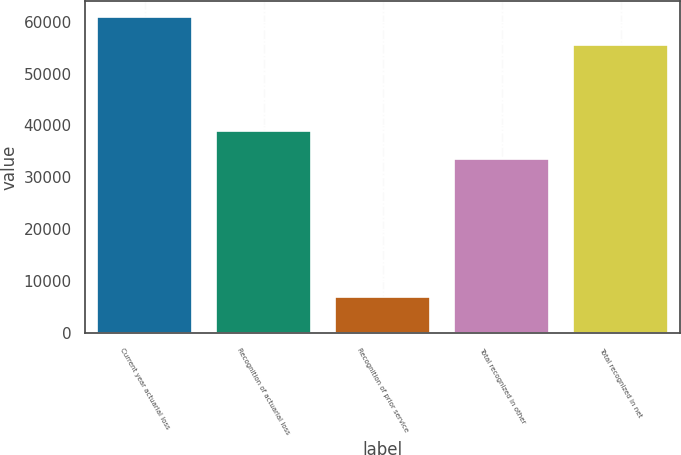<chart> <loc_0><loc_0><loc_500><loc_500><bar_chart><fcel>Current year actuarial loss<fcel>Recognition of actuarial loss<fcel>Recognition of prior service<fcel>Total recognized in other<fcel>Total recognized in net<nl><fcel>60903.8<fcel>39019.8<fcel>6979<fcel>33640<fcel>55524<nl></chart> 